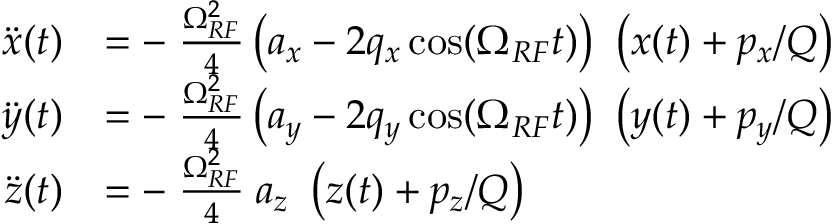Convert formula to latex. <formula><loc_0><loc_0><loc_500><loc_500>\begin{array} { r l } { \ddot { x } ( t ) } & { = - \, \frac { \Omega _ { R F } ^ { 2 } } { 4 } \left ( a _ { x } - 2 q _ { x } \cos ( \Omega _ { R F } t ) \right ) \ \left ( x ( t ) + p _ { x } / Q \right ) } \\ { \ddot { y } ( t ) } & { = - \, \frac { \Omega _ { R F } ^ { 2 } } { 4 } \left ( a _ { y } - 2 q _ { y } \cos ( \Omega _ { R F } t ) \right ) \ \left ( y ( t ) + p _ { y } / Q \right ) } \\ { \ddot { z } ( t ) } & { = - \, \frac { \Omega _ { R F } ^ { 2 } } { 4 } \, a _ { z } \ \left ( z ( t ) + p _ { z } / Q \right ) } \end{array}</formula> 